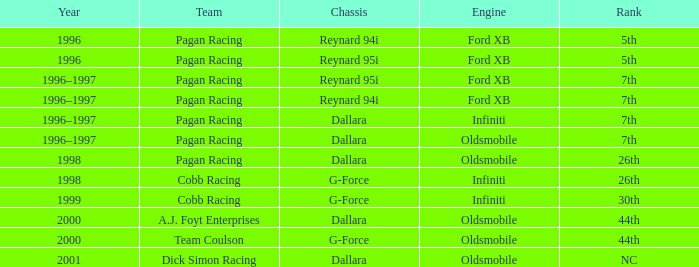What rank did the dallara chassis finish in 2000? 44th. 